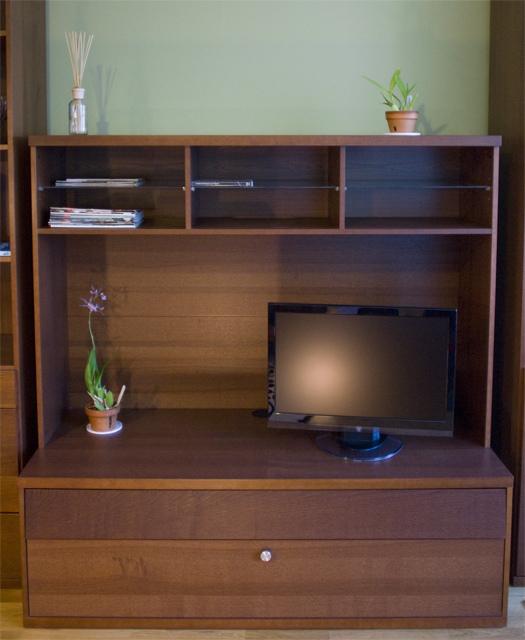What is sitting by the t.v.?
Short answer required. Plant. What color is the wall?
Concise answer only. Green. Where is the modem?
Short answer required. Desk. How many plants are in the picture?
Short answer required. 2. Is this a flat screen TV?
Answer briefly. Yes. How many drawers are shown?
Answer briefly. 1. What is cast?
Keep it brief. Nothing. 